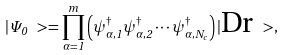Convert formula to latex. <formula><loc_0><loc_0><loc_500><loc_500>| \Psi _ { 0 } \ > = \prod _ { \alpha = 1 } ^ { m } \left ( \psi ^ { \dag } _ { \alpha , 1 } \psi ^ { \dag } _ { \alpha , 2 } \cdots \psi ^ { \dag } _ { \alpha , N _ { c } } \right ) | \text {Dr} \ > ,</formula> 